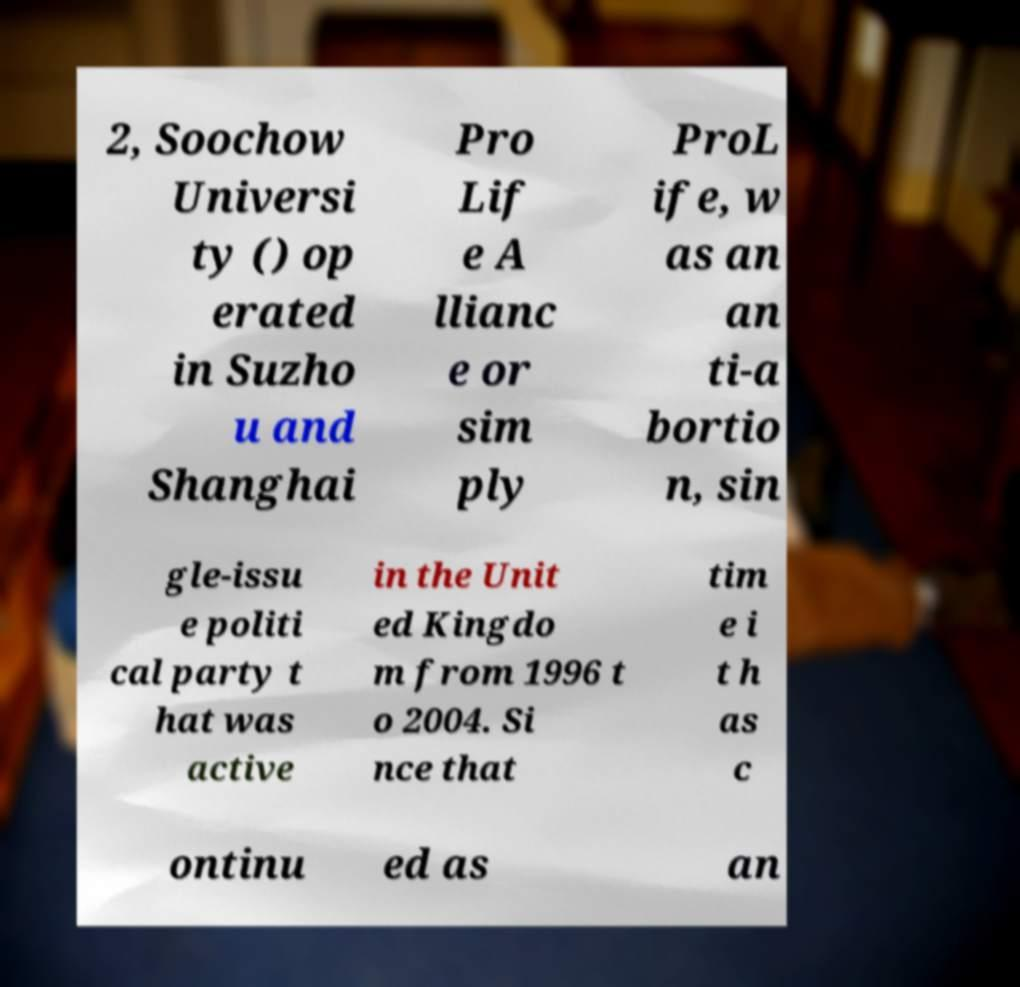Can you accurately transcribe the text from the provided image for me? 2, Soochow Universi ty () op erated in Suzho u and Shanghai Pro Lif e A llianc e or sim ply ProL ife, w as an an ti-a bortio n, sin gle-issu e politi cal party t hat was active in the Unit ed Kingdo m from 1996 t o 2004. Si nce that tim e i t h as c ontinu ed as an 